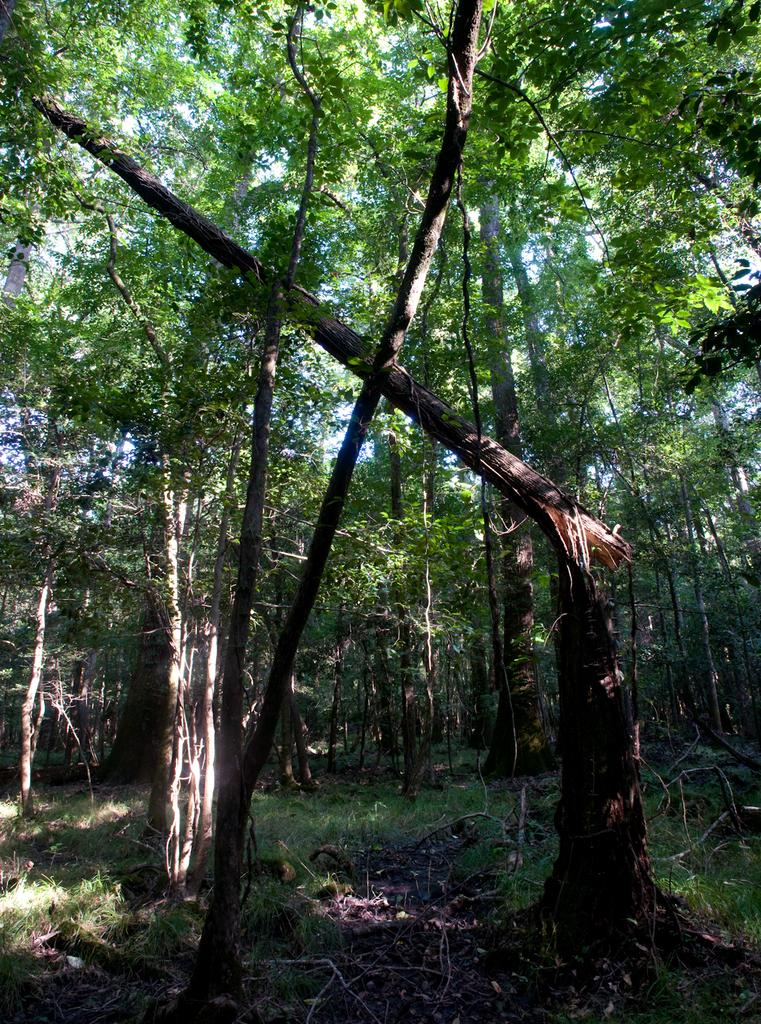What type of vegetation can be seen in the image? There are trees in the image. What type of ground cover is present in the image? There is grass on the land in the image. What part of the natural environment is visible in the image? The sky is visible in the background of the image. What type of experience can be gained from the hydrant in the image? There is no hydrant present in the image, so no experience can be gained from it. 